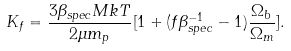Convert formula to latex. <formula><loc_0><loc_0><loc_500><loc_500>K _ { f } = \frac { 3 \beta _ { s p e c } M k T } { 2 \mu m _ { p } } [ 1 + ( f \beta _ { s p e c } ^ { - 1 } - 1 ) \frac { \Omega _ { b } } { \Omega _ { m } } ] .</formula> 